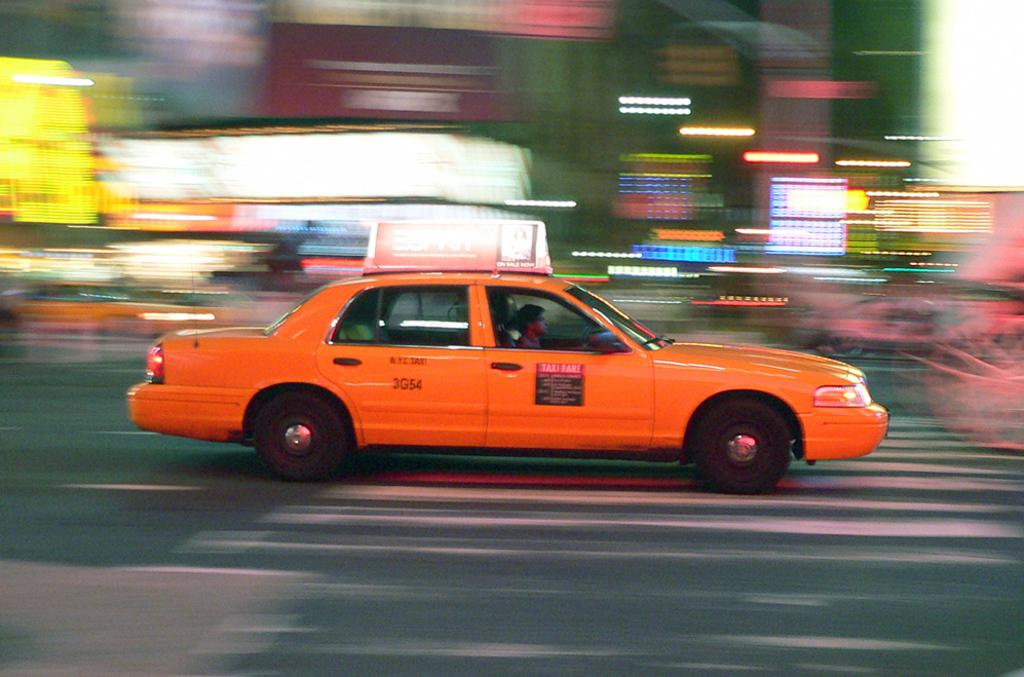<image>
Share a concise interpretation of the image provided. The price of the taxi fares is posted on the side of the cab. 